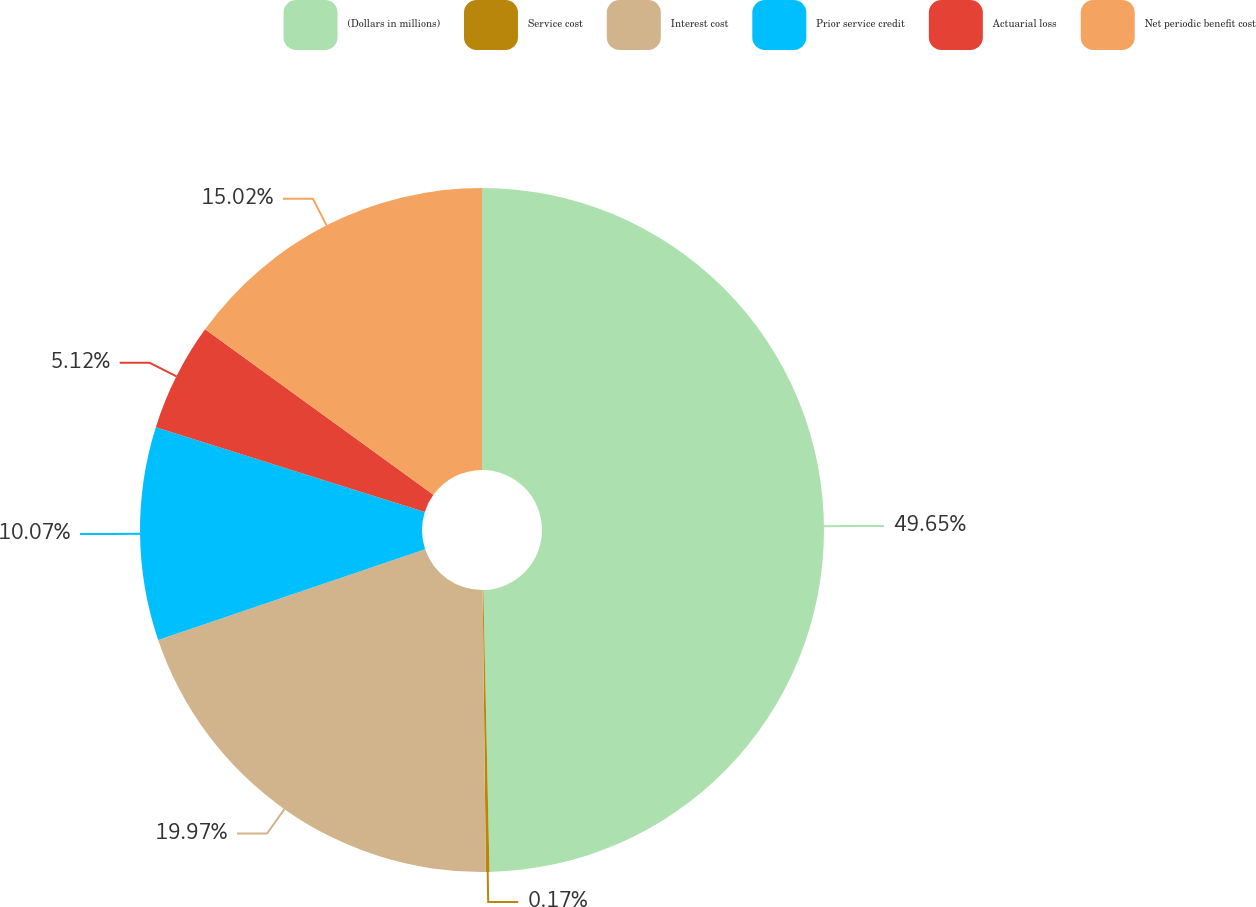Convert chart. <chart><loc_0><loc_0><loc_500><loc_500><pie_chart><fcel>(Dollars in millions)<fcel>Service cost<fcel>Interest cost<fcel>Prior service credit<fcel>Actuarial loss<fcel>Net periodic benefit cost<nl><fcel>49.65%<fcel>0.17%<fcel>19.97%<fcel>10.07%<fcel>5.12%<fcel>15.02%<nl></chart> 